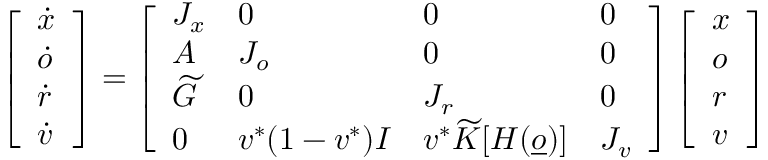<formula> <loc_0><loc_0><loc_500><loc_500>\left [ \begin{array} { l } { \dot { x } } \\ { \dot { o } } \\ { \dot { r } } \\ { \dot { v } } \end{array} \right ] = \left [ \begin{array} { l l l l } { J _ { x } } & { 0 } & { 0 } & { 0 } \\ { A } & { J _ { o } } & { 0 } & { 0 } \\ { \widetilde { G } } & { 0 } & { J _ { r } } & { 0 } \\ { 0 } & { v ^ { * } ( 1 - v ^ { * } ) I } & { v ^ { * } \widetilde { K } [ H ( \underline { o } ) ] } & { J _ { v } } \end{array} \right ] \left [ \begin{array} { l } { x } \\ { o } \\ { r } \\ { v } \end{array} \right ]</formula> 